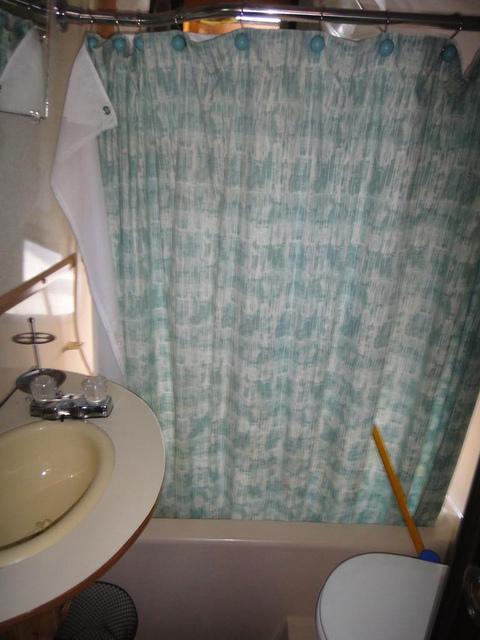What room is this?
Quick response, please. Bathroom. What color is the curtain?
Answer briefly. Green. Do you see a sink?
Answer briefly. Yes. 